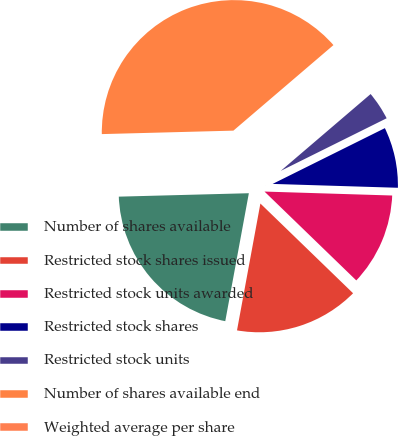Convert chart to OTSL. <chart><loc_0><loc_0><loc_500><loc_500><pie_chart><fcel>Number of shares available<fcel>Restricted stock shares issued<fcel>Restricted stock units awarded<fcel>Restricted stock shares<fcel>Restricted stock units<fcel>Number of shares available end<fcel>Weighted average per share<nl><fcel>21.68%<fcel>15.66%<fcel>11.75%<fcel>7.83%<fcel>3.92%<fcel>39.16%<fcel>0.0%<nl></chart> 